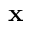<formula> <loc_0><loc_0><loc_500><loc_500>x</formula> 